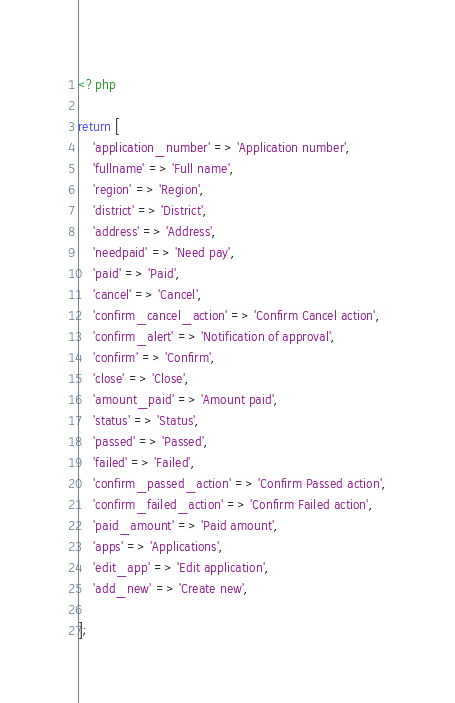<code> <loc_0><loc_0><loc_500><loc_500><_PHP_><?php

return [
    'application_number' => 'Application number',
    'fullname' => 'Full name',
    'region' => 'Region',
    'district' => 'District',
    'address' => 'Address',
    'needpaid' => 'Need pay',
    'paid' => 'Paid',
    'cancel' => 'Cancel',
    'confirm_cancel_action' => 'Confirm Cancel action',
    'confirm_alert' => 'Notification of approval',
    'confirm' => 'Confirm',
    'close' => 'Close',
    'amount_paid' => 'Amount paid',
    'status' => 'Status',
    'passed' => 'Passed',
    'failed' => 'Failed',
    'confirm_passed_action' => 'Confirm Passed action',
    'confirm_failed_action' => 'Confirm Failed action',
    'paid_amount' => 'Paid amount',
    'apps' => 'Applications',
    'edit_app' => 'Edit application',
    'add_new' => 'Create new',

];
</code> 